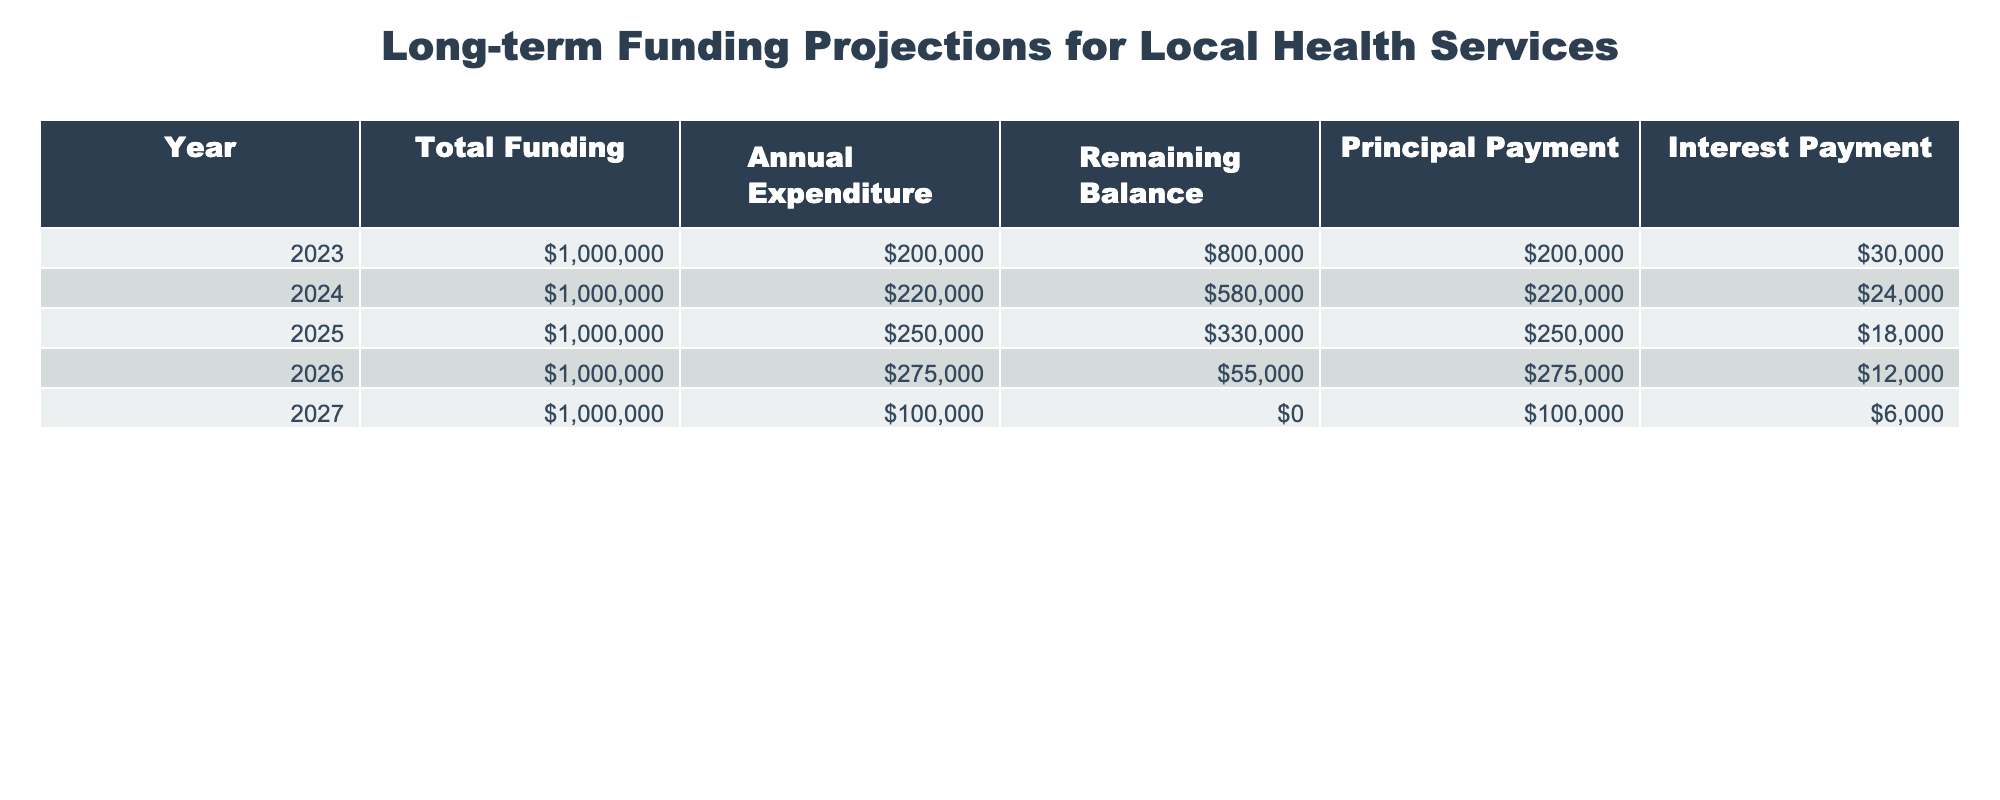What is the total funding allocated for the year 2025? The table specifies that the total funding for each year is the same at 1,000,000. Thus, for the year 2025, the total funding is 1,000,000.
Answer: 1,000,000 What was the remaining balance at the end of 2024? In the table, the remaining balance for the year 2024 is listed as 580,000.
Answer: 580,000 How much did the annual expenditure increase from 2023 to 2024? The annual expenditure for 2023 is 200,000 and for 2024 is 220,000. The increase is calculated as 220,000 - 200,000 = 20,000.
Answer: 20,000 Is the annual expenditure for 2025 greater than the total funding? The annual expenditure for 2025 is 250,000, which is less than the total funding of 1,000,000. Therefore, the statement is false.
Answer: No What is the average principal payment over the five years? The principal payments across the years are 200,000, 220,000, 250,000, 275,000, and 100,000. To find the average, add these together: 200,000 + 220,000 + 250,000 + 275,000 + 100,000 = 1,045,000, then divide by 5, which equals 209,000.
Answer: 209,000 In which year did the local health services incur the highest annual expenditure? The expenditures for each year are 200,000 (2023), 220,000 (2024), 250,000 (2025), 275,000 (2026), and 100,000 (2027). The highest expenditure of 275,000 occurred in 2026.
Answer: 2026 What is the difference between the total funding and the remaining balance at the end of 2025? The total funding for each year is 1,000,000 and the remaining balance at the end of 2025 is 330,000. The difference is calculated as 1,000,000 - 330,000 = 670,000.
Answer: 670,000 Is the interest payment in 2024 lower than that in 2025? The interest payment for 2024 is 24,000, and for 2025 it is 18,000. Since 24,000 is greater than 18,000, the statement is false.
Answer: No What was the total amount paid in principal payments across all years? The principal payments are 200,000 (2023), 220,000 (2024), 250,000 (2025), 275,000 (2026), and 100,000 (2027). Summing these gives: 200,000 + 220,000 + 250,000 + 275,000 + 100,000 = 1,045,000.
Answer: 1,045,000 